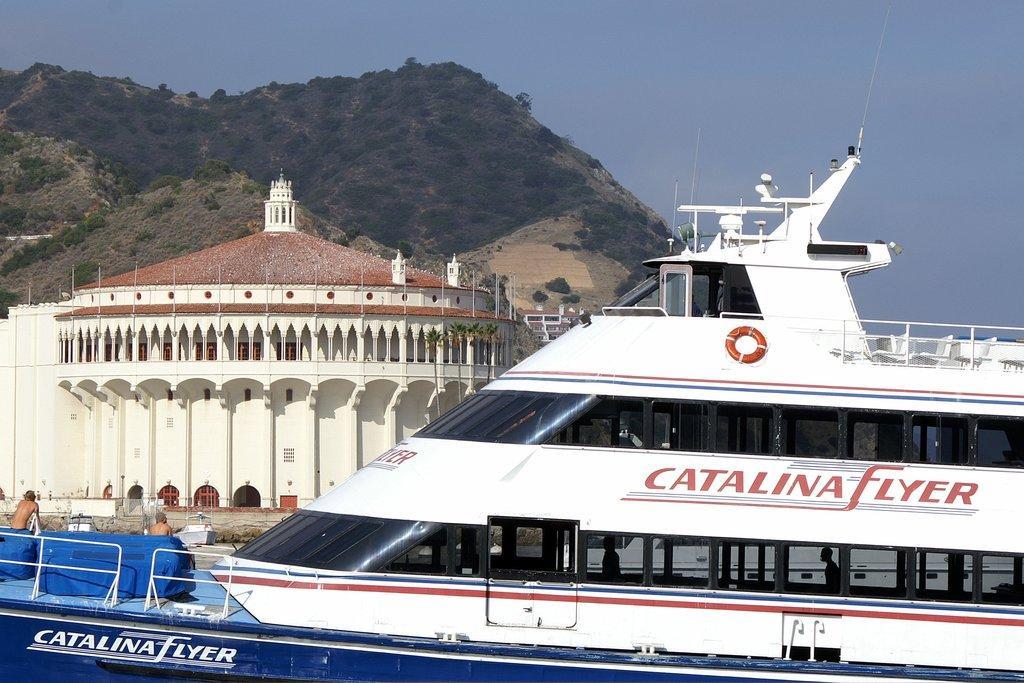Describe this image in one or two sentences. On the right side it's a ship which is in white color and on the left side there is a house on the back side it's a hill. 